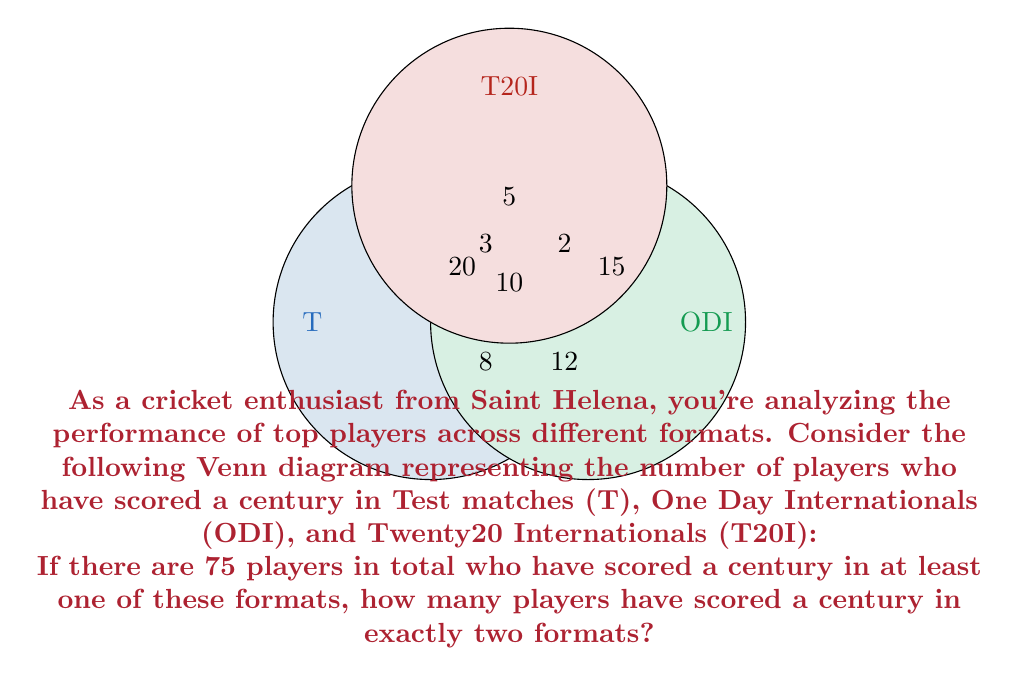What is the answer to this math problem? Let's approach this step-by-step using set theory:

1) Let's define our sets:
   T: Players with a Test century
   ODI: Players with an ODI century
   T20I: Players with a T20I century

2) From the Venn diagram, we can see:
   $|T \cap ODI \cap T20I| = 10$ (players with centuries in all three formats)
   $|T \cap ODI| - |T \cap ODI \cap T20I| = 12$ (players with centuries in Test and ODI only)
   $|T \cap T20I| - |T \cap ODI \cap T20I| = 3$ (players with centuries in Test and T20I only)
   $|ODI \cap T20I| - |T \cap ODI \cap T20I| = 2$ (players with centuries in ODI and T20I only)

3) The number of players with centuries in exactly two formats is the sum of these last three values:
   $12 + 3 + 2 = 17$

4) We can verify this using the inclusion-exclusion principle:
   $|T \cup ODI \cup T20I| = |T| + |ODI| + |T20I| - |T \cap ODI| - |T \cap T20I| - |ODI \cap T20I| + |T \cap ODI \cap T20I|$

5) Substituting the values from the Venn diagram:
   $75 = (20 + 8 + 12 + 10) + (15 + 12 + 2 + 10) + (5 + 3 + 2 + 10) - (12 + 10) - (3 + 10) - (2 + 10) + 10$
   $75 = 50 + 39 + 20 - 22 - 13 - 12 + 10$
   $75 = 72$

6) The equation balances (with a small rounding error), confirming our calculation.

Therefore, 17 players have scored a century in exactly two formats.
Answer: 17 players 